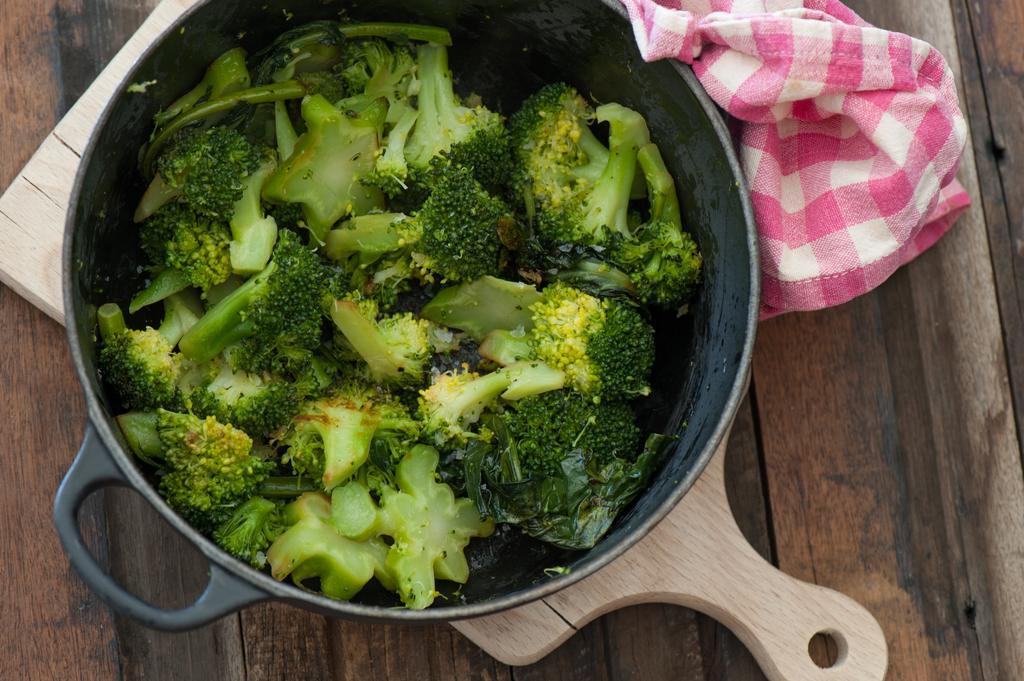What is the main object in the image? There is a pan in the image. Where is the pan placed? The pan is on a wooden plank. What is the wooden plank resting on? The wooden plank is on a wooden table. Is there any covering on the wooden table? Yes, there is a cloth on the wooden table. What is inside the pan? A: There are broccoli in the pan. What letters are being used to spell out a word on the broccoli in the image? There are no letters present on the broccoli in the image. What type of neck accessory is visible on the wooden table in the image? There is no neck accessory present on the wooden table in the image. 